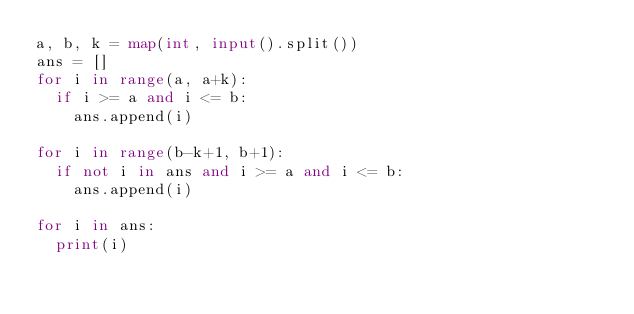Convert code to text. <code><loc_0><loc_0><loc_500><loc_500><_Python_>a, b, k = map(int, input().split())
ans = []
for i in range(a, a+k):
  if i >= a and i <= b:
    ans.append(i)

for i in range(b-k+1, b+1):
  if not i in ans and i >= a and i <= b:
    ans.append(i)

for i in ans:
  print(i)</code> 